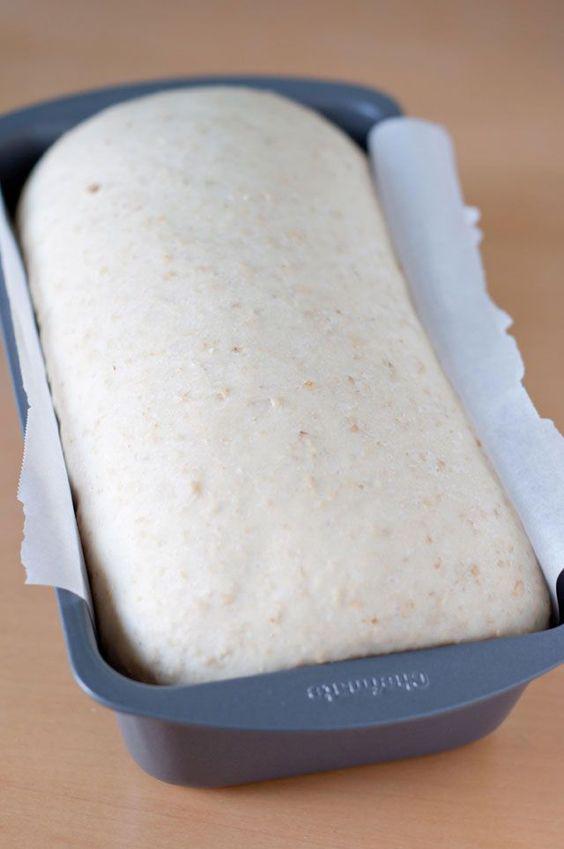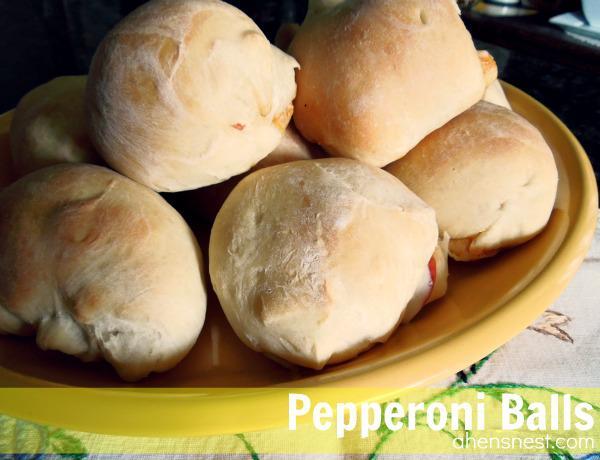The first image is the image on the left, the second image is the image on the right. Given the left and right images, does the statement "Each image contains one rounded ball of raw dough." hold true? Answer yes or no. No. The first image is the image on the left, the second image is the image on the right. For the images displayed, is the sentence "The left and right image contains the same number of balls of dough." factually correct? Answer yes or no. No. 